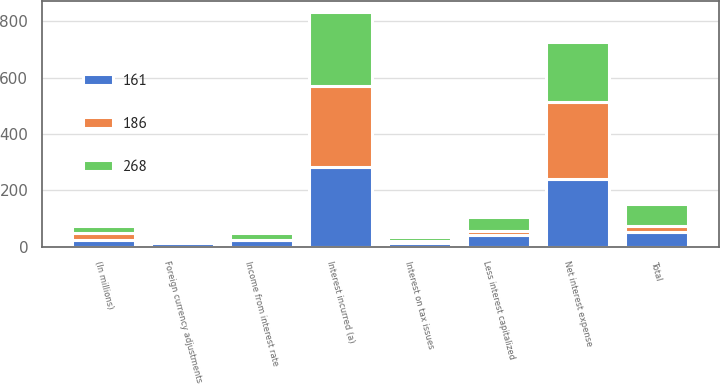Convert chart. <chart><loc_0><loc_0><loc_500><loc_500><stacked_bar_chart><ecel><fcel>(In millions)<fcel>Income from interest rate<fcel>Foreign currency adjustments<fcel>Total<fcel>Interest incurred (a)<fcel>Less interest capitalized<fcel>Net interest expense<fcel>Interest on tax issues<nl><fcel>268<fcel>24<fcel>24<fcel>9<fcel>78<fcel>262<fcel>48<fcel>214<fcel>12<nl><fcel>161<fcel>24<fcel>23<fcel>13<fcel>52<fcel>282<fcel>41<fcel>241<fcel>13<nl><fcel>186<fcel>24<fcel>2<fcel>8<fcel>20<fcel>288<fcel>16<fcel>272<fcel>9<nl></chart> 